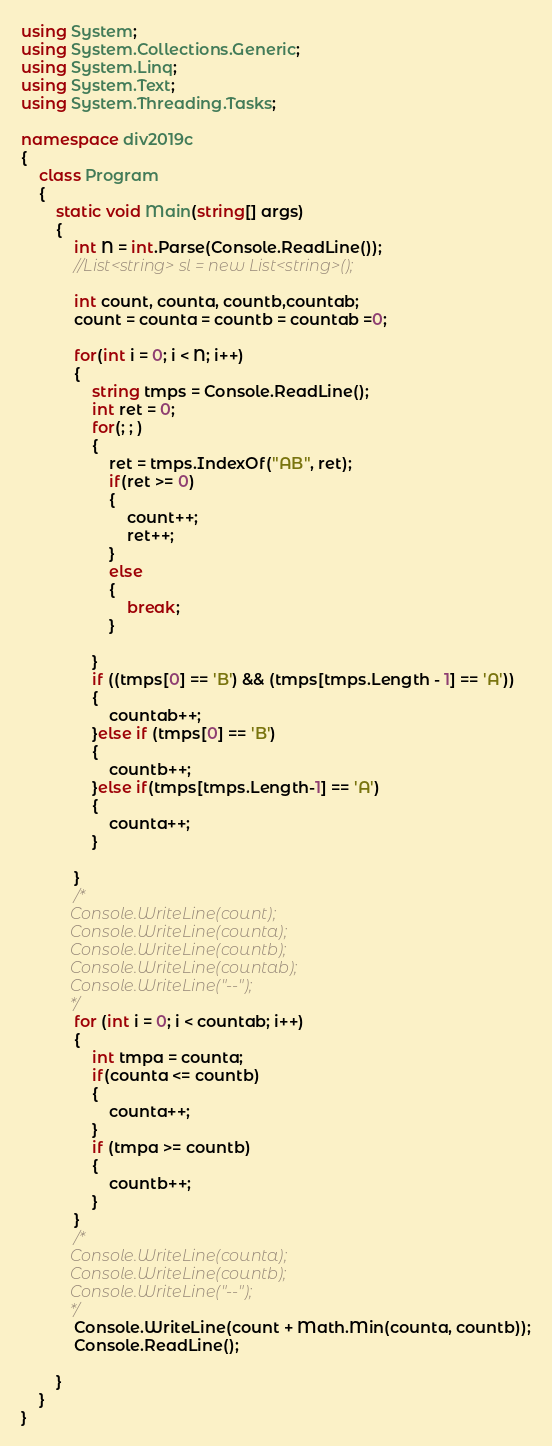<code> <loc_0><loc_0><loc_500><loc_500><_C#_>using System;
using System.Collections.Generic;
using System.Linq;
using System.Text;
using System.Threading.Tasks;

namespace div2019c
{
    class Program
    {
        static void Main(string[] args)
        {
            int N = int.Parse(Console.ReadLine());
            //List<string> sl = new List<string>();

            int count, counta, countb,countab;
            count = counta = countb = countab =0;

            for(int i = 0; i < N; i++)
            {
                string tmps = Console.ReadLine();
                int ret = 0;
                for(; ; )
                {
                    ret = tmps.IndexOf("AB", ret);
                    if(ret >= 0)
                    {
                        count++;
                        ret++;
                    }
                    else
                    {
                        break;
                    }

                }
                if ((tmps[0] == 'B') && (tmps[tmps.Length - 1] == 'A'))
                {
                    countab++;
                }else if (tmps[0] == 'B')
                {
                    countb++;
                }else if(tmps[tmps.Length-1] == 'A')
                {
                    counta++;
                }

            }
            /*
            Console.WriteLine(count);
            Console.WriteLine(counta);
            Console.WriteLine(countb);
            Console.WriteLine(countab);
            Console.WriteLine("--");
            */
            for (int i = 0; i < countab; i++)
            {
                int tmpa = counta;
                if(counta <= countb)
                {
                    counta++;
                }
                if (tmpa >= countb)
                {
                    countb++;
                }
            }
            /*
            Console.WriteLine(counta);
            Console.WriteLine(countb);
            Console.WriteLine("--");
            */
            Console.WriteLine(count + Math.Min(counta, countb));
            Console.ReadLine();

        }
    }
}
</code> 